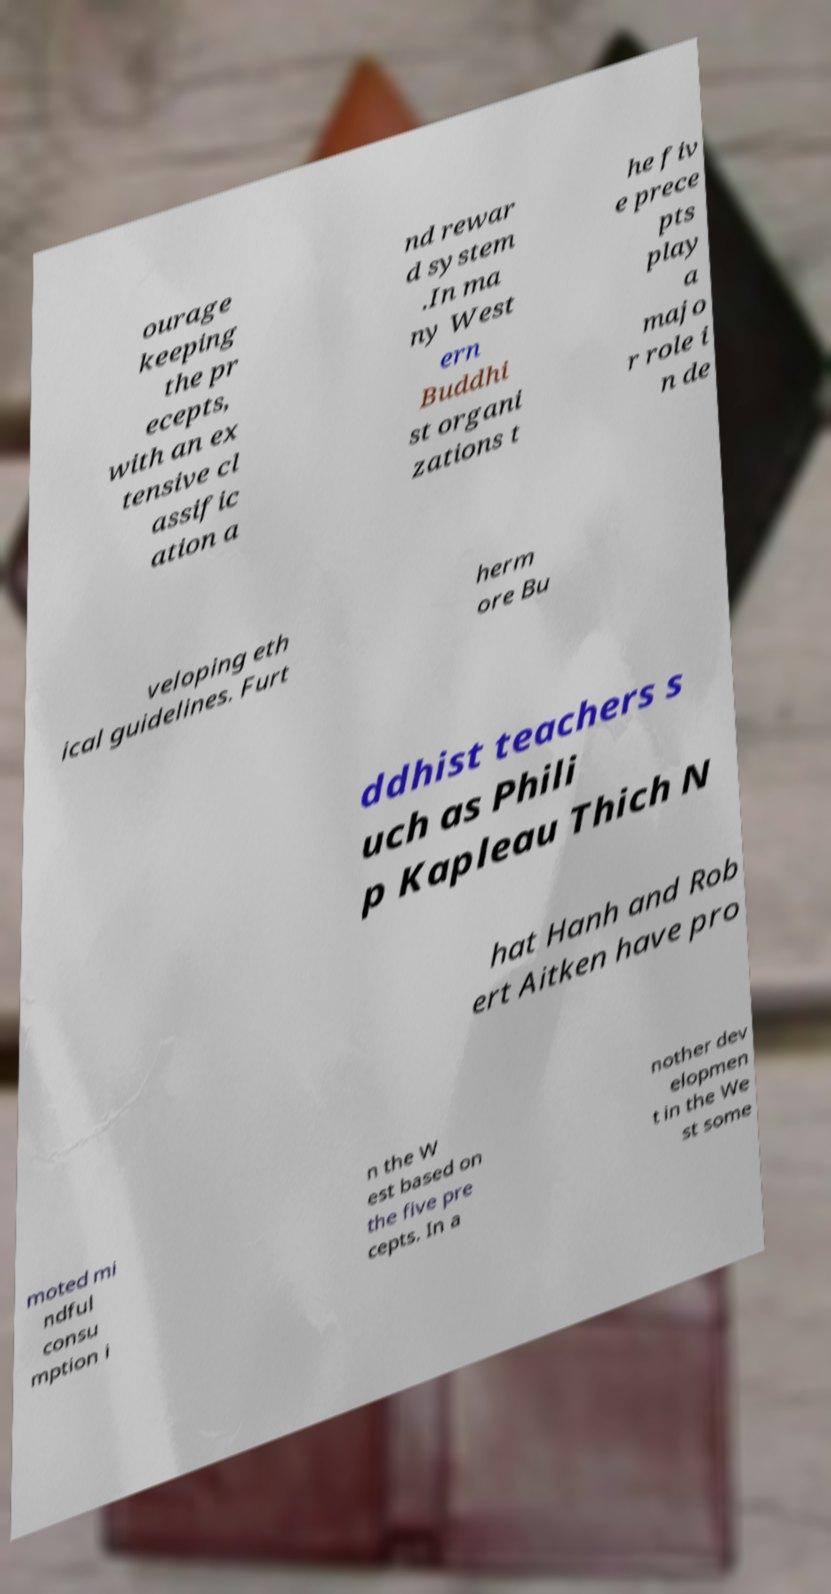For documentation purposes, I need the text within this image transcribed. Could you provide that? ourage keeping the pr ecepts, with an ex tensive cl assific ation a nd rewar d system .In ma ny West ern Buddhi st organi zations t he fiv e prece pts play a majo r role i n de veloping eth ical guidelines. Furt herm ore Bu ddhist teachers s uch as Phili p Kapleau Thich N hat Hanh and Rob ert Aitken have pro moted mi ndful consu mption i n the W est based on the five pre cepts. In a nother dev elopmen t in the We st some 